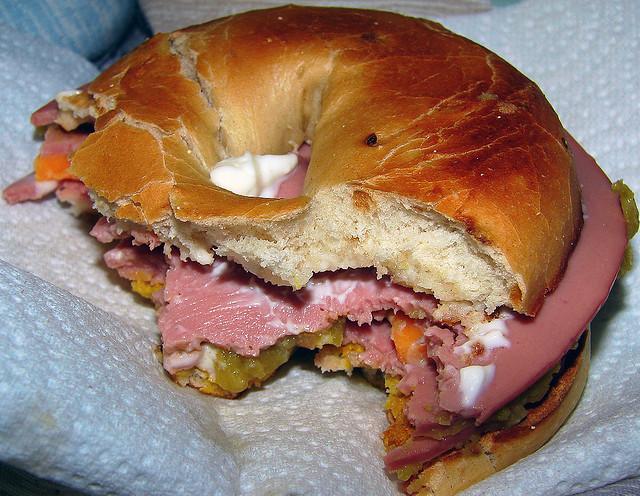Has someone at half of the sandwich?
Write a very short answer. Yes. What is this food?
Give a very brief answer. Sandwich. What is this type of bread called?
Quick response, please. Bagel. Is this a whole sandwich?
Keep it brief. No. Is this a bagel sandwich?
Short answer required. Yes. 